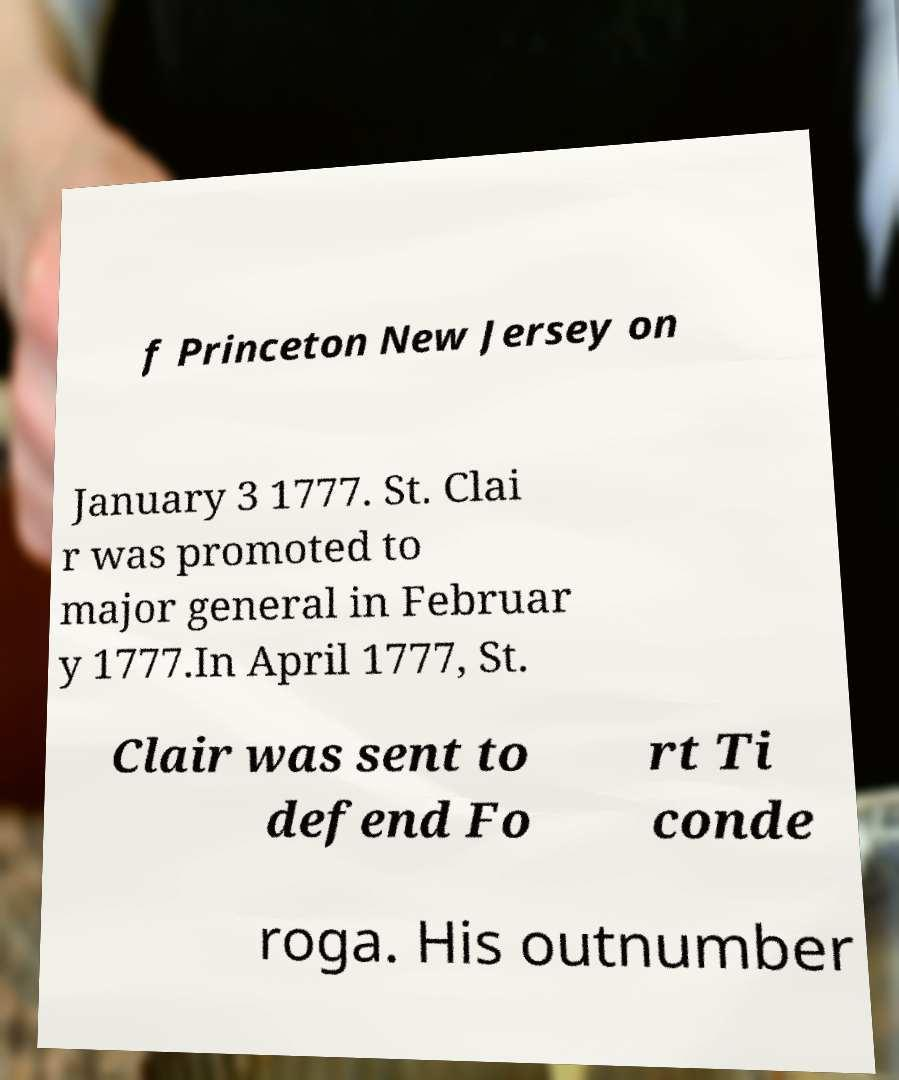There's text embedded in this image that I need extracted. Can you transcribe it verbatim? f Princeton New Jersey on January 3 1777. St. Clai r was promoted to major general in Februar y 1777.In April 1777, St. Clair was sent to defend Fo rt Ti conde roga. His outnumber 